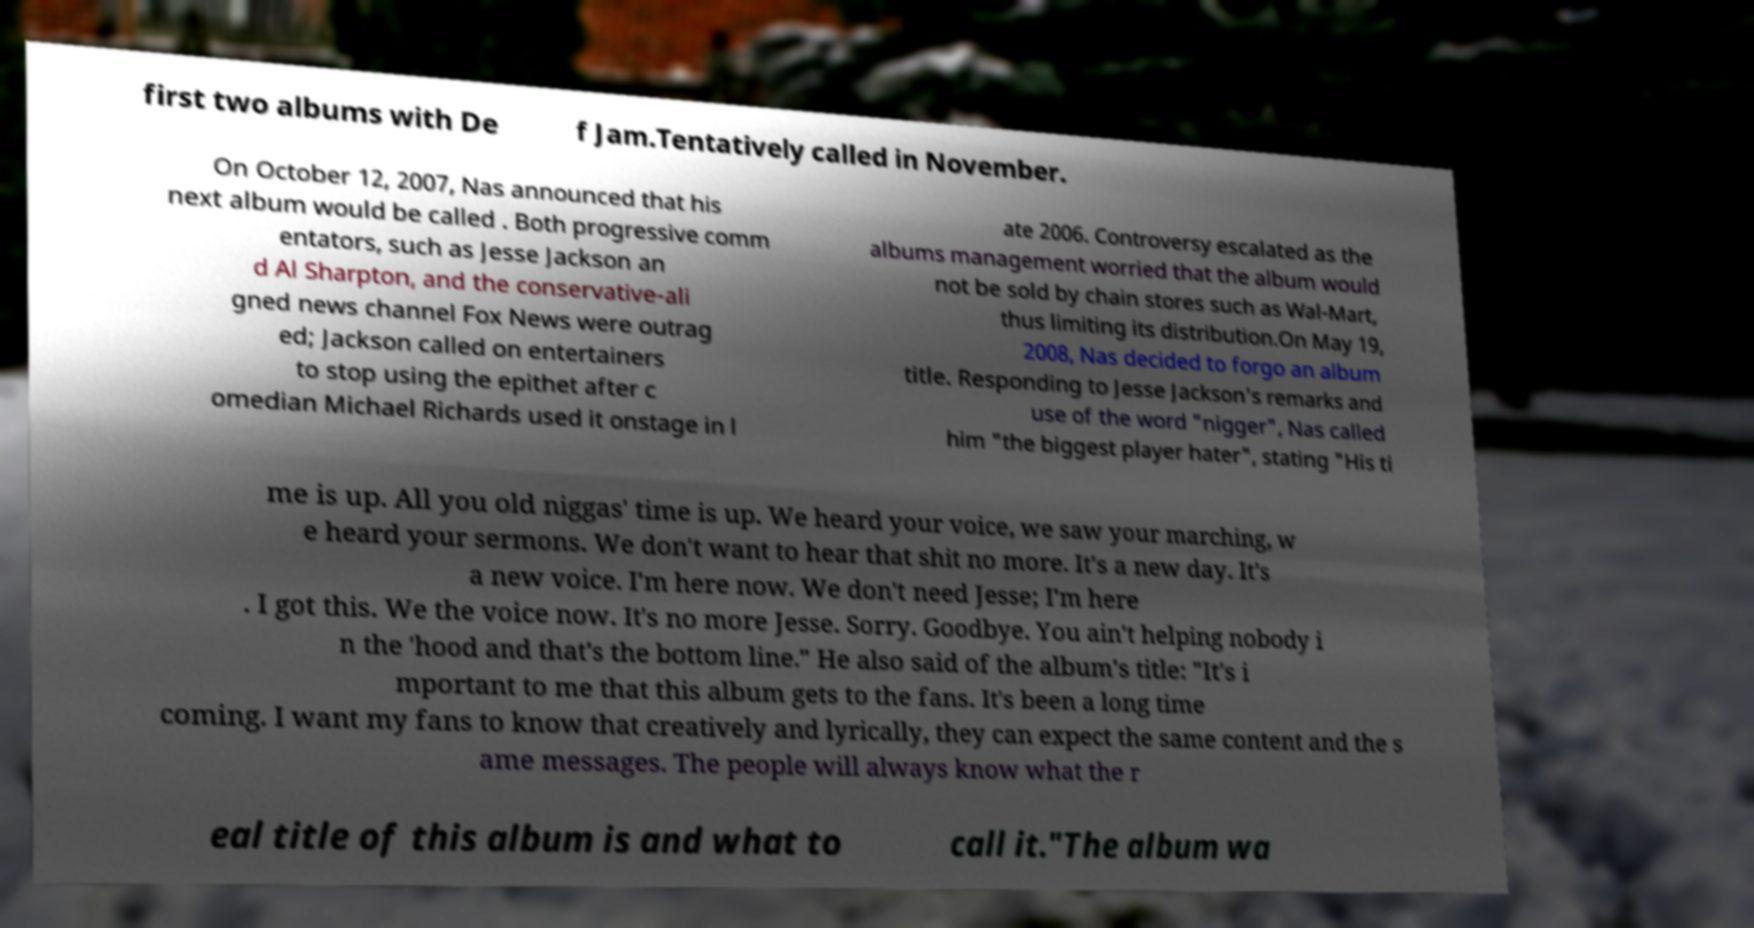Please read and relay the text visible in this image. What does it say? first two albums with De f Jam.Tentatively called in November. On October 12, 2007, Nas announced that his next album would be called . Both progressive comm entators, such as Jesse Jackson an d Al Sharpton, and the conservative-ali gned news channel Fox News were outrag ed; Jackson called on entertainers to stop using the epithet after c omedian Michael Richards used it onstage in l ate 2006. Controversy escalated as the albums management worried that the album would not be sold by chain stores such as Wal-Mart, thus limiting its distribution.On May 19, 2008, Nas decided to forgo an album title. Responding to Jesse Jackson's remarks and use of the word "nigger", Nas called him "the biggest player hater", stating "His ti me is up. All you old niggas' time is up. We heard your voice, we saw your marching, w e heard your sermons. We don't want to hear that shit no more. It's a new day. It's a new voice. I'm here now. We don't need Jesse; I'm here . I got this. We the voice now. It's no more Jesse. Sorry. Goodbye. You ain't helping nobody i n the 'hood and that's the bottom line." He also said of the album's title: "It's i mportant to me that this album gets to the fans. It's been a long time coming. I want my fans to know that creatively and lyrically, they can expect the same content and the s ame messages. The people will always know what the r eal title of this album is and what to call it."The album wa 